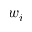<formula> <loc_0><loc_0><loc_500><loc_500>w _ { i }</formula> 